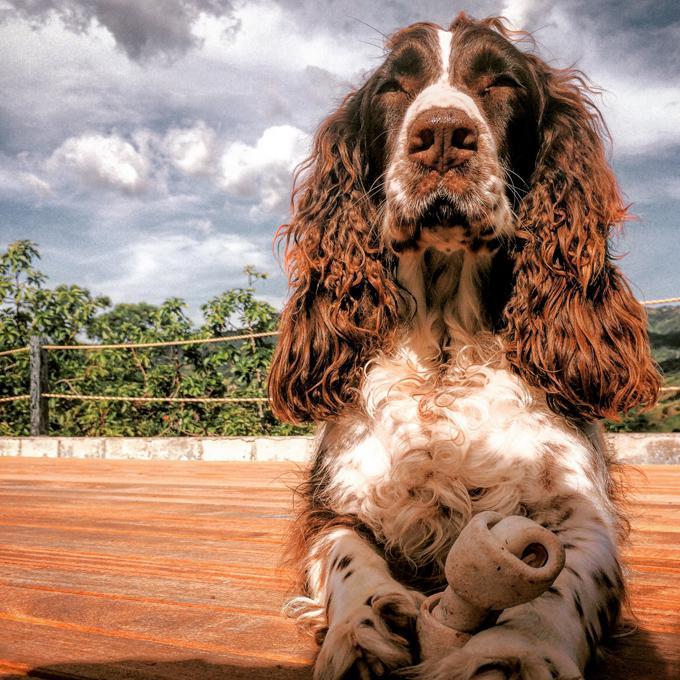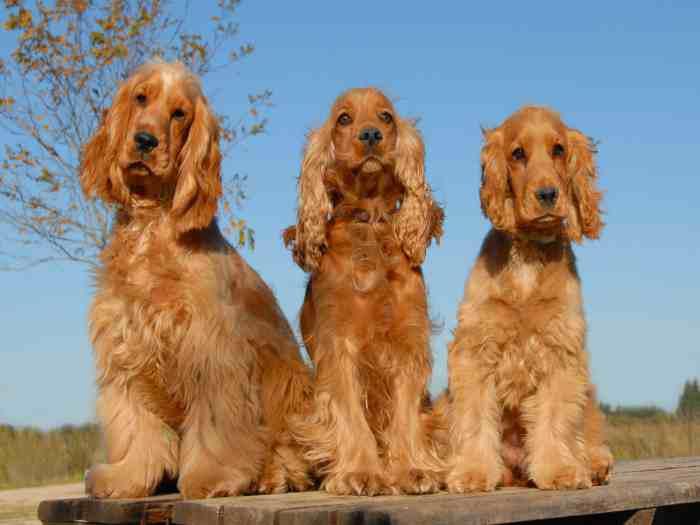The first image is the image on the left, the second image is the image on the right. Considering the images on both sides, is "An image shows one reclining dog with a paw on an object." valid? Answer yes or no. Yes. 